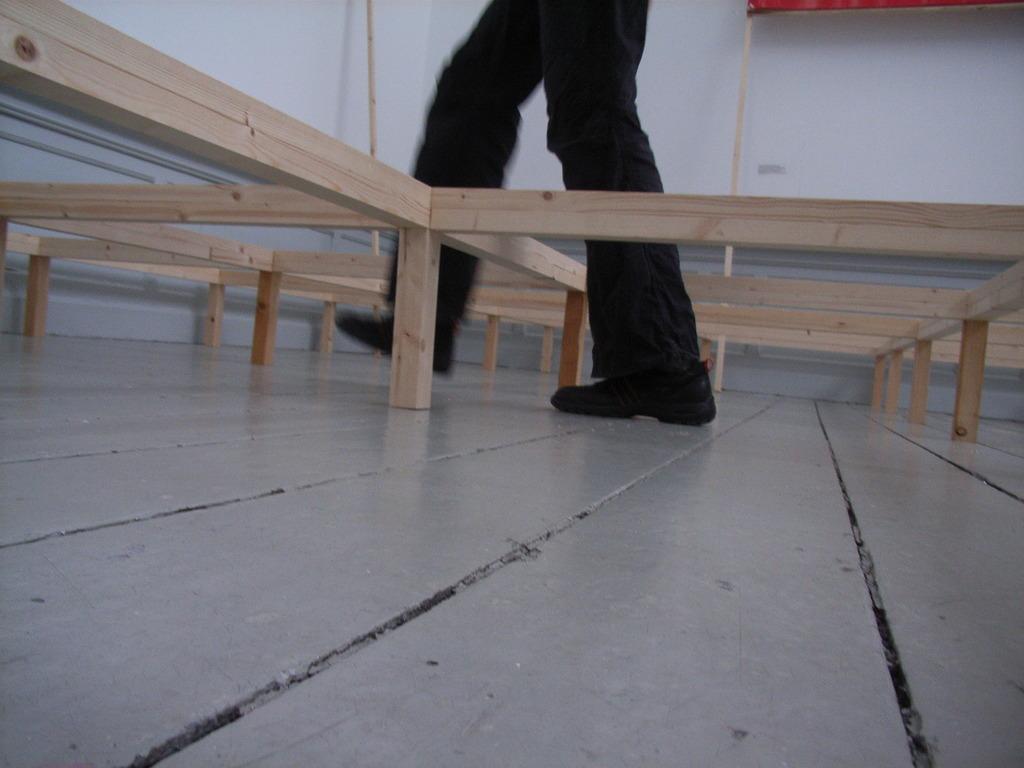Please provide a concise description of this image. In this image in the center there is a person walking and there are wooden stands and there is a wall which is white in colour and on the top right there is an object which is red in colour. 